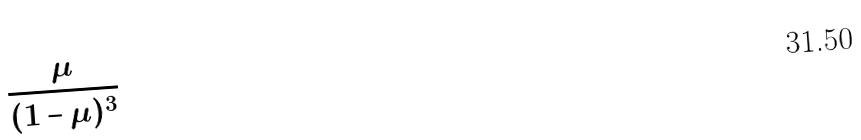<formula> <loc_0><loc_0><loc_500><loc_500>\frac { \mu } { ( 1 - \mu ) ^ { 3 } }</formula> 